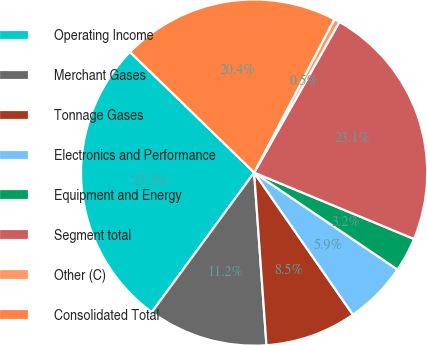Convert chart. <chart><loc_0><loc_0><loc_500><loc_500><pie_chart><fcel>Operating Income<fcel>Merchant Gases<fcel>Tonnage Gases<fcel>Electronics and Performance<fcel>Equipment and Energy<fcel>Segment total<fcel>Other (C)<fcel>Consolidated Total<nl><fcel>27.2%<fcel>11.2%<fcel>8.53%<fcel>5.87%<fcel>3.2%<fcel>23.07%<fcel>0.53%<fcel>20.4%<nl></chart> 